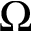Convert formula to latex. <formula><loc_0><loc_0><loc_500><loc_500>\Omega</formula> 